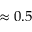Convert formula to latex. <formula><loc_0><loc_0><loc_500><loc_500>\approx 0 . 5</formula> 